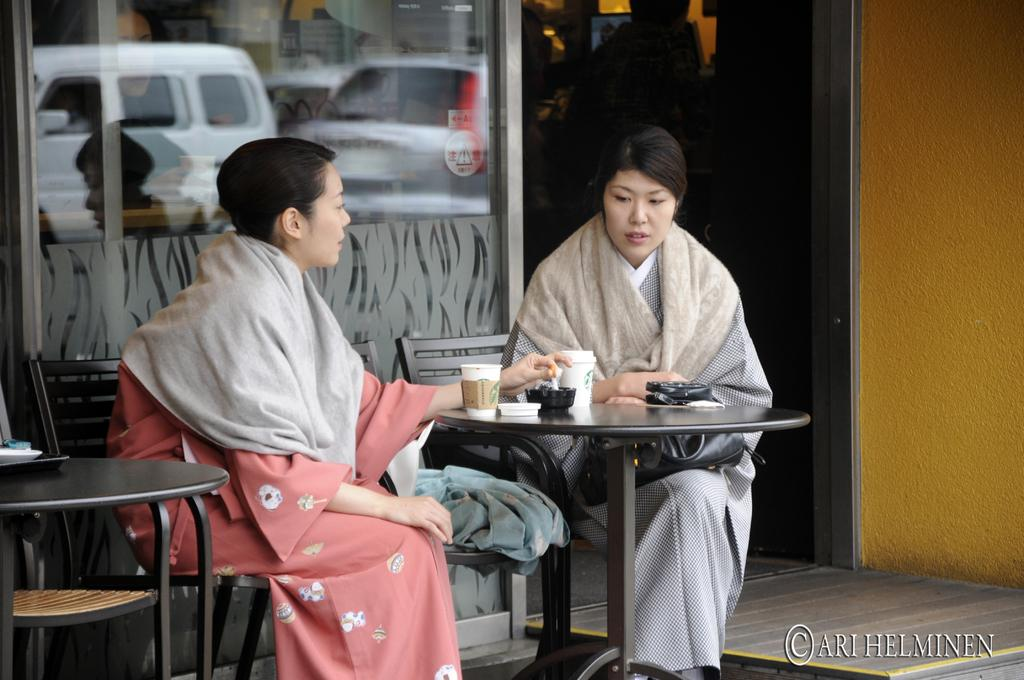How many women are in the image? There are two women in the image. What are the women doing in the image? The women are sitting on a chair. What is present on the table in the image? There is a cap and a bowl on the table. What can be seen in the mirror in the image? There are reflections of a car on the mirror. What type of harmony is being played by the team in the image? There is no mention of harmony or a team in the image; it features two women sitting on a chair with a table and a mirror. 